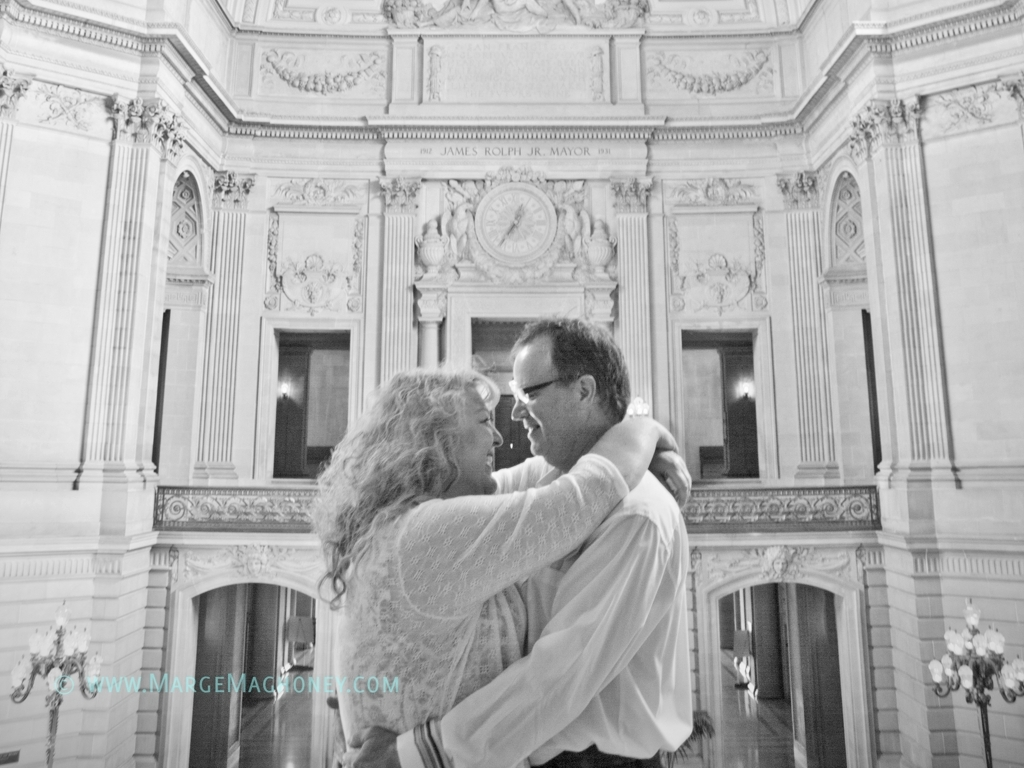Can you describe the architectural style visible in the background? The architectural style in the background is characteristic of classic Beaux-Arts architecture. This style is renowned for its grandeur and richly detailed decorations, including elaborate sculptures, columns, and ornate moldings. The design elements suggest a sophisticated and elegant environment, likely intended to convey prestige and historical importance. 